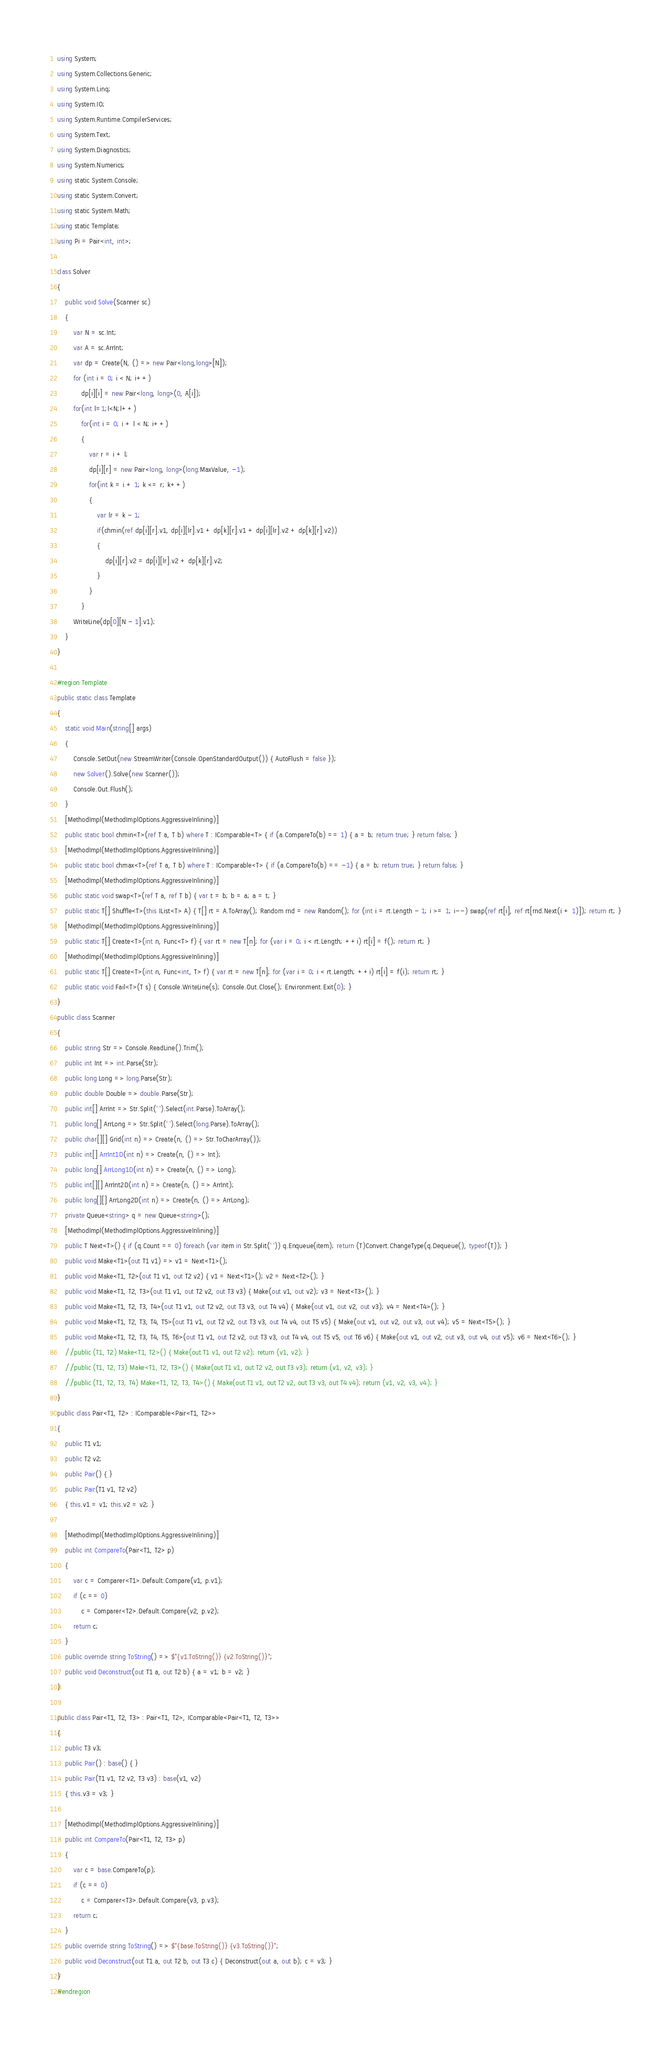Convert code to text. <code><loc_0><loc_0><loc_500><loc_500><_C#_>using System;
using System.Collections.Generic;
using System.Linq;
using System.IO;
using System.Runtime.CompilerServices;
using System.Text;
using System.Diagnostics;
using System.Numerics;
using static System.Console;
using static System.Convert;
using static System.Math;
using static Template;
using Pi = Pair<int, int>;

class Solver
{
    public void Solve(Scanner sc)
    {
        var N = sc.Int;
        var A = sc.ArrInt;
        var dp = Create(N, () => new Pair<long,long>[N]);
        for (int i = 0; i < N; i++)
            dp[i][i] = new Pair<long, long>(0, A[i]);
        for(int l=1;l<N;l++)
            for(int i = 0; i + l < N; i++)
            {
                var r = i + l;
                dp[i][r] = new Pair<long, long>(long.MaxValue, -1);
                for(int k = i + 1; k <= r; k++)
                {
                    var lr = k - 1;
                    if(chmin(ref dp[i][r].v1, dp[i][lr].v1 + dp[k][r].v1 + dp[i][lr].v2 + dp[k][r].v2))
                    {
                        dp[i][r].v2 = dp[i][lr].v2 + dp[k][r].v2;
                    }
                }
            }
        WriteLine(dp[0][N - 1].v1);
    }
}

#region Template
public static class Template
{
    static void Main(string[] args)
    {
        Console.SetOut(new StreamWriter(Console.OpenStandardOutput()) { AutoFlush = false });
        new Solver().Solve(new Scanner());
        Console.Out.Flush();
    }
    [MethodImpl(MethodImplOptions.AggressiveInlining)]
    public static bool chmin<T>(ref T a, T b) where T : IComparable<T> { if (a.CompareTo(b) == 1) { a = b; return true; } return false; }
    [MethodImpl(MethodImplOptions.AggressiveInlining)]
    public static bool chmax<T>(ref T a, T b) where T : IComparable<T> { if (a.CompareTo(b) == -1) { a = b; return true; } return false; }
    [MethodImpl(MethodImplOptions.AggressiveInlining)]
    public static void swap<T>(ref T a, ref T b) { var t = b; b = a; a = t; }
    public static T[] Shuffle<T>(this IList<T> A) { T[] rt = A.ToArray(); Random rnd = new Random(); for (int i = rt.Length - 1; i >= 1; i--) swap(ref rt[i], ref rt[rnd.Next(i + 1)]); return rt; }
    [MethodImpl(MethodImplOptions.AggressiveInlining)]
    public static T[] Create<T>(int n, Func<T> f) { var rt = new T[n]; for (var i = 0; i < rt.Length; ++i) rt[i] = f(); return rt; }
    [MethodImpl(MethodImplOptions.AggressiveInlining)]
    public static T[] Create<T>(int n, Func<int, T> f) { var rt = new T[n]; for (var i = 0; i < rt.Length; ++i) rt[i] = f(i); return rt; }
    public static void Fail<T>(T s) { Console.WriteLine(s); Console.Out.Close(); Environment.Exit(0); }
}
public class Scanner
{
    public string Str => Console.ReadLine().Trim();
    public int Int => int.Parse(Str);
    public long Long => long.Parse(Str);
    public double Double => double.Parse(Str);
    public int[] ArrInt => Str.Split(' ').Select(int.Parse).ToArray();
    public long[] ArrLong => Str.Split(' ').Select(long.Parse).ToArray();
    public char[][] Grid(int n) => Create(n, () => Str.ToCharArray());
    public int[] ArrInt1D(int n) => Create(n, () => Int);
    public long[] ArrLong1D(int n) => Create(n, () => Long);
    public int[][] ArrInt2D(int n) => Create(n, () => ArrInt);
    public long[][] ArrLong2D(int n) => Create(n, () => ArrLong);
    private Queue<string> q = new Queue<string>();
    [MethodImpl(MethodImplOptions.AggressiveInlining)]
    public T Next<T>() { if (q.Count == 0) foreach (var item in Str.Split(' ')) q.Enqueue(item); return (T)Convert.ChangeType(q.Dequeue(), typeof(T)); }
    public void Make<T1>(out T1 v1) => v1 = Next<T1>();
    public void Make<T1, T2>(out T1 v1, out T2 v2) { v1 = Next<T1>(); v2 = Next<T2>(); }
    public void Make<T1, T2, T3>(out T1 v1, out T2 v2, out T3 v3) { Make(out v1, out v2); v3 = Next<T3>(); }
    public void Make<T1, T2, T3, T4>(out T1 v1, out T2 v2, out T3 v3, out T4 v4) { Make(out v1, out v2, out v3); v4 = Next<T4>(); }
    public void Make<T1, T2, T3, T4, T5>(out T1 v1, out T2 v2, out T3 v3, out T4 v4, out T5 v5) { Make(out v1, out v2, out v3, out v4); v5 = Next<T5>(); }
    public void Make<T1, T2, T3, T4, T5, T6>(out T1 v1, out T2 v2, out T3 v3, out T4 v4, out T5 v5, out T6 v6) { Make(out v1, out v2, out v3, out v4, out v5); v6 = Next<T6>(); }
    //public (T1, T2) Make<T1, T2>() { Make(out T1 v1, out T2 v2); return (v1, v2); }
    //public (T1, T2, T3) Make<T1, T2, T3>() { Make(out T1 v1, out T2 v2, out T3 v3); return (v1, v2, v3); }
    //public (T1, T2, T3, T4) Make<T1, T2, T3, T4>() { Make(out T1 v1, out T2 v2, out T3 v3, out T4 v4); return (v1, v2, v3, v4); }
}
public class Pair<T1, T2> : IComparable<Pair<T1, T2>>
{
    public T1 v1;
    public T2 v2;
    public Pair() { }
    public Pair(T1 v1, T2 v2)
    { this.v1 = v1; this.v2 = v2; }

    [MethodImpl(MethodImplOptions.AggressiveInlining)]
    public int CompareTo(Pair<T1, T2> p)
    {
        var c = Comparer<T1>.Default.Compare(v1, p.v1);
        if (c == 0)
            c = Comparer<T2>.Default.Compare(v2, p.v2);
        return c;
    }
    public override string ToString() => $"{v1.ToString()} {v2.ToString()}";
    public void Deconstruct(out T1 a, out T2 b) { a = v1; b = v2; }
}

public class Pair<T1, T2, T3> : Pair<T1, T2>, IComparable<Pair<T1, T2, T3>>
{
    public T3 v3;
    public Pair() : base() { }
    public Pair(T1 v1, T2 v2, T3 v3) : base(v1, v2)
    { this.v3 = v3; }

    [MethodImpl(MethodImplOptions.AggressiveInlining)]
    public int CompareTo(Pair<T1, T2, T3> p)
    {
        var c = base.CompareTo(p);
        if (c == 0)
            c = Comparer<T3>.Default.Compare(v3, p.v3);
        return c;
    }
    public override string ToString() => $"{base.ToString()} {v3.ToString()}";
    public void Deconstruct(out T1 a, out T2 b, out T3 c) { Deconstruct(out a, out b); c = v3; }
}
#endregion</code> 